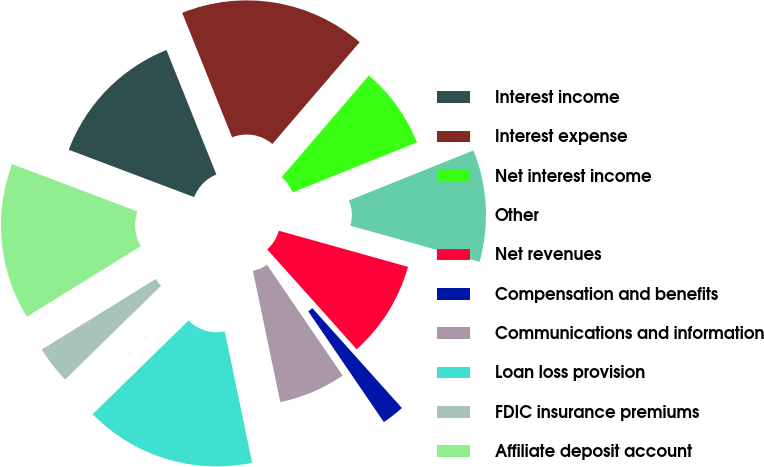Convert chart to OTSL. <chart><loc_0><loc_0><loc_500><loc_500><pie_chart><fcel>Interest income<fcel>Interest expense<fcel>Net interest income<fcel>Other<fcel>Net revenues<fcel>Compensation and benefits<fcel>Communications and information<fcel>Loan loss provision<fcel>FDIC insurance premiums<fcel>Affiliate deposit account<nl><fcel>13.19%<fcel>17.35%<fcel>7.64%<fcel>10.42%<fcel>9.03%<fcel>2.1%<fcel>6.26%<fcel>15.96%<fcel>3.49%<fcel>14.57%<nl></chart> 